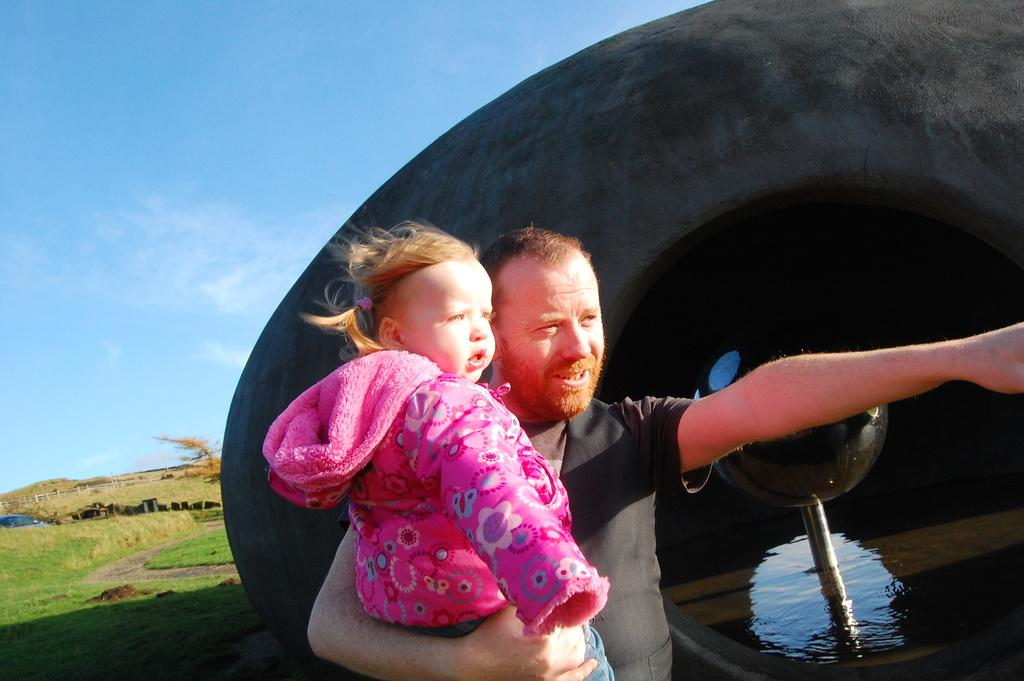What can be seen in the sky in the image? Sky is visible in the image. What type of terrain is present in the image? There is grass in the image. How many people are in the image? There are two people in the image. What else can be seen in the image besides the sky and grass? Water is visible in the image, as well as a cave. What book is one of the people reading in the image? There is no book or reading activity present in the image. 